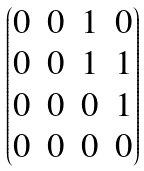<formula> <loc_0><loc_0><loc_500><loc_500>\begin{pmatrix} 0 & 0 & 1 & 0 \\ 0 & 0 & 1 & 1 \\ 0 & 0 & 0 & 1 \\ 0 & 0 & 0 & 0 \end{pmatrix}</formula> 